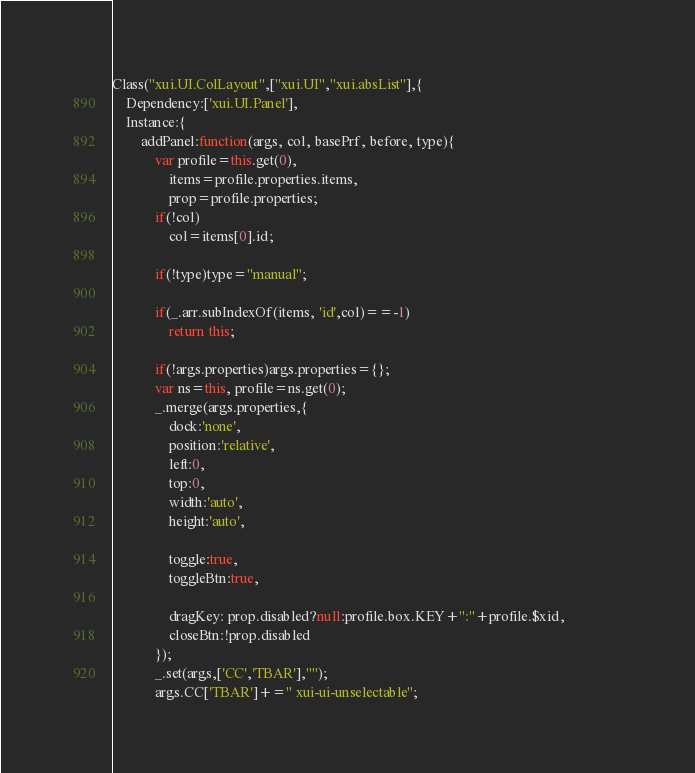<code> <loc_0><loc_0><loc_500><loc_500><_JavaScript_>Class("xui.UI.ColLayout",["xui.UI","xui.absList"],{
    Dependency:['xui.UI.Panel'],
    Instance:{
        addPanel:function(args, col, basePrf, before, type){
            var profile=this.get(0),
                items=profile.properties.items,
                prop=profile.properties;
            if(!col)
                col=items[0].id;

            if(!type)type="manual";

            if(_.arr.subIndexOf(items, 'id',col)==-1)
                return this;
            
            if(!args.properties)args.properties={};
            var ns=this, profile=ns.get(0);
            _.merge(args.properties,{   
                dock:'none',
                position:'relative',
                left:0,
                top:0,
                width:'auto',
                height:'auto',
                
                toggle:true,
                toggleBtn:true,
                
                dragKey: prop.disabled?null:profile.box.KEY+":"+profile.$xid,                
                closeBtn:!prop.disabled 
            });
            _.set(args,['CC','TBAR'],"");
            args.CC['TBAR']+=" xui-ui-unselectable";
</code> 